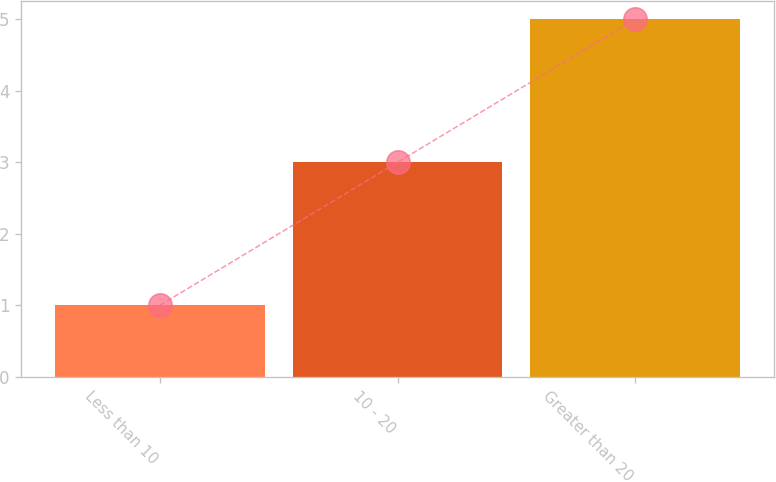Convert chart. <chart><loc_0><loc_0><loc_500><loc_500><bar_chart><fcel>Less than 10<fcel>10 - 20<fcel>Greater than 20<nl><fcel>1<fcel>3<fcel>5<nl></chart> 